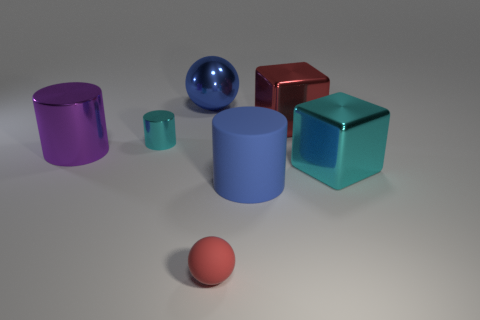Is the shape of the large rubber thing the same as the blue metal object?
Make the answer very short. No. What number of spheres are big rubber things or large red objects?
Your answer should be very brief. 0. The large cylinder that is the same material as the small cyan thing is what color?
Your response must be concise. Purple. Is the size of the rubber thing that is in front of the matte cylinder the same as the metallic sphere?
Offer a very short reply. No. Is the big purple cylinder made of the same material as the ball on the right side of the large sphere?
Make the answer very short. No. The tiny object right of the blue sphere is what color?
Your response must be concise. Red. There is a blue object that is behind the large purple cylinder; are there any large blue matte cylinders behind it?
Offer a terse response. No. There is a matte object on the right side of the red matte ball; does it have the same color as the big cylinder that is left of the tiny cyan object?
Keep it short and to the point. No. There is a big red thing; how many objects are behind it?
Make the answer very short. 1. What number of blocks have the same color as the small metal object?
Make the answer very short. 1. 